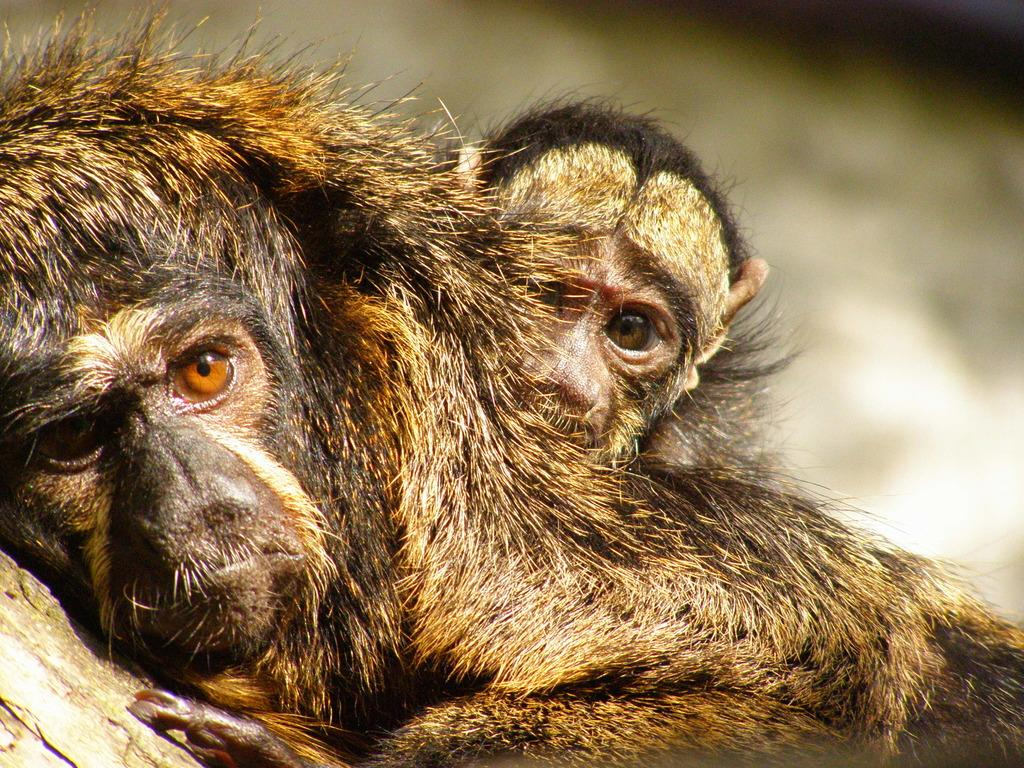What type of animal is in the image? There is a chimpanzee in the image. Can you describe the color of the chimpanzee? The chimpanzee has a black and brown color combination. What is the chimpanzee lying on in the image? The chimpanzee is lying on a wooden surface. Are there any other chimpanzees in the image? Yes, there is another chimpanzee in the image. How would you describe the background of the image? The background of the image is blurred. What type of yarn is the chimpanzee holding in the image? There is no yarn present in the image; the chimpanzee is lying on a wooden surface. How does the chimpanzee move around in the image? The chimpanzee does not move around in the image; it is lying on a wooden surface. 